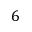Convert formula to latex. <formula><loc_0><loc_0><loc_500><loc_500>6</formula> 